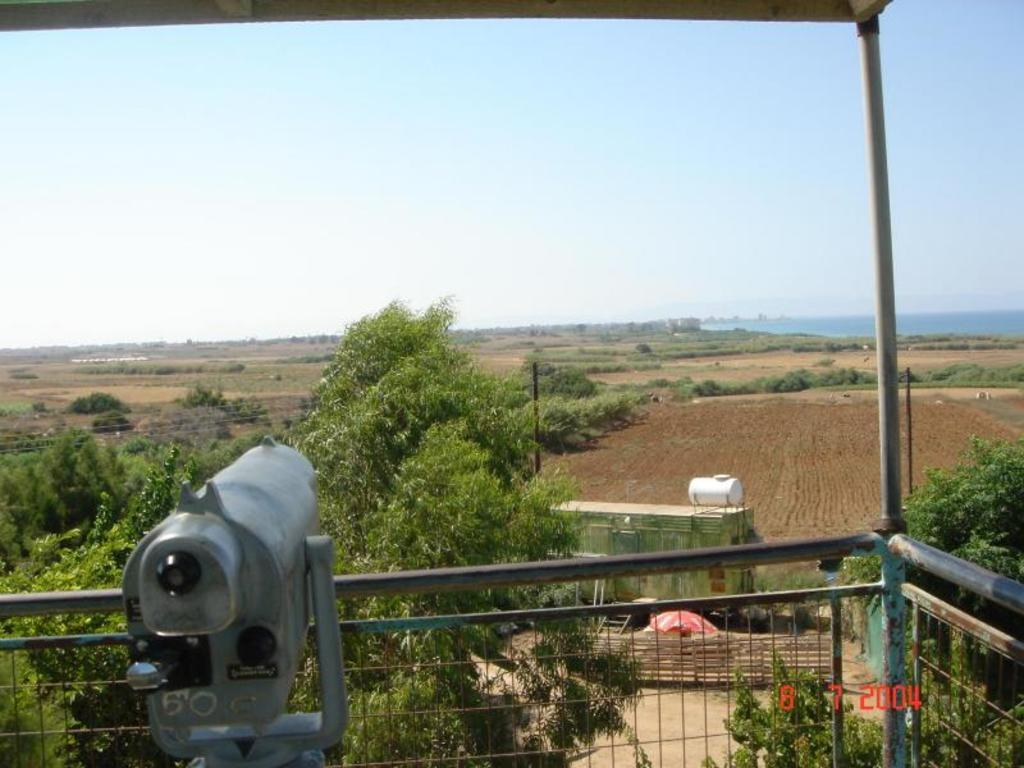What type of metal object is in the image? The fact does not specify the type of metal object, only that there is a metal object present. What is the fence made of in the image? The fence in the image is made of metal. What type of vegetation can be seen in the image? There are plants, grass, and trees visible in the image. What is the ground like in the image? The ground is visible in the image, and there are some objects on it. What else can be seen in the image besides the metal object and the fence? There are wires, plants, grass, trees, and the sky visible in the image. Can you see a mountain in the image? No, there is no mountain present in the image. Are there any bees buzzing around the plants in the image? The image does not show any bees; it only shows plants, trees, and other objects. 